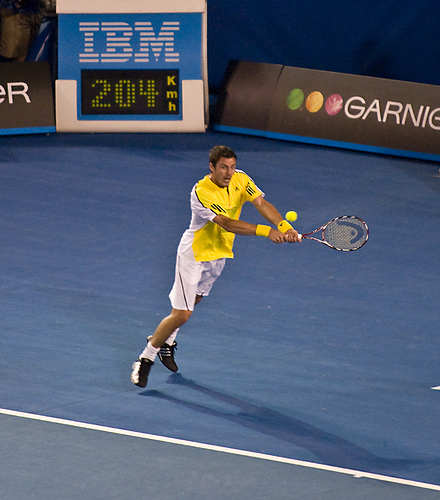Identify the text contained in this image. IBM 204 Kmh GARNI R 